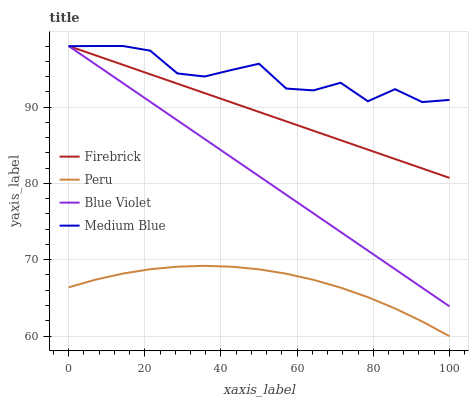Does Peru have the minimum area under the curve?
Answer yes or no. Yes. Does Medium Blue have the maximum area under the curve?
Answer yes or no. Yes. Does Blue Violet have the minimum area under the curve?
Answer yes or no. No. Does Blue Violet have the maximum area under the curve?
Answer yes or no. No. Is Firebrick the smoothest?
Answer yes or no. Yes. Is Medium Blue the roughest?
Answer yes or no. Yes. Is Blue Violet the smoothest?
Answer yes or no. No. Is Blue Violet the roughest?
Answer yes or no. No. Does Peru have the lowest value?
Answer yes or no. Yes. Does Blue Violet have the lowest value?
Answer yes or no. No. Does Blue Violet have the highest value?
Answer yes or no. Yes. Does Peru have the highest value?
Answer yes or no. No. Is Peru less than Blue Violet?
Answer yes or no. Yes. Is Blue Violet greater than Peru?
Answer yes or no. Yes. Does Medium Blue intersect Blue Violet?
Answer yes or no. Yes. Is Medium Blue less than Blue Violet?
Answer yes or no. No. Is Medium Blue greater than Blue Violet?
Answer yes or no. No. Does Peru intersect Blue Violet?
Answer yes or no. No. 